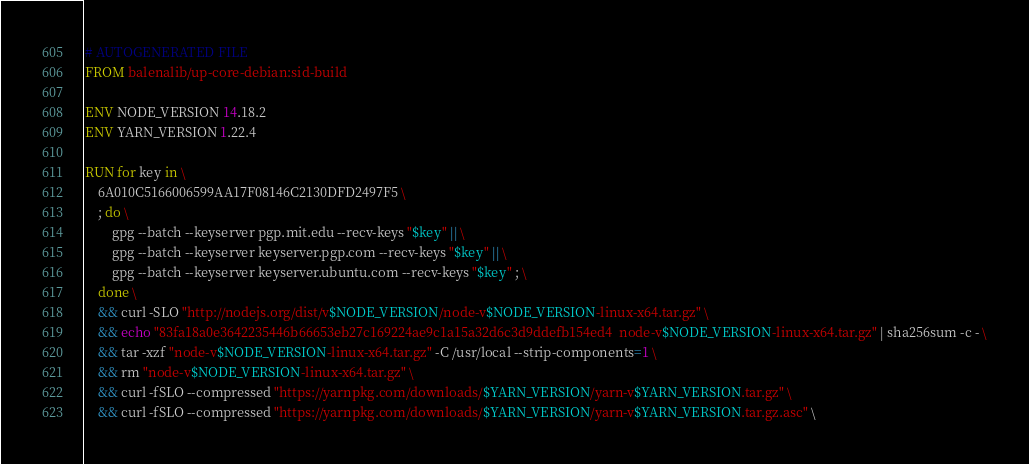<code> <loc_0><loc_0><loc_500><loc_500><_Dockerfile_># AUTOGENERATED FILE
FROM balenalib/up-core-debian:sid-build

ENV NODE_VERSION 14.18.2
ENV YARN_VERSION 1.22.4

RUN for key in \
	6A010C5166006599AA17F08146C2130DFD2497F5 \
	; do \
		gpg --batch --keyserver pgp.mit.edu --recv-keys "$key" || \
		gpg --batch --keyserver keyserver.pgp.com --recv-keys "$key" || \
		gpg --batch --keyserver keyserver.ubuntu.com --recv-keys "$key" ; \
	done \
	&& curl -SLO "http://nodejs.org/dist/v$NODE_VERSION/node-v$NODE_VERSION-linux-x64.tar.gz" \
	&& echo "83fa18a0e3642235446b66653eb27c169224ae9c1a15a32d6c3d9ddefb154ed4  node-v$NODE_VERSION-linux-x64.tar.gz" | sha256sum -c - \
	&& tar -xzf "node-v$NODE_VERSION-linux-x64.tar.gz" -C /usr/local --strip-components=1 \
	&& rm "node-v$NODE_VERSION-linux-x64.tar.gz" \
	&& curl -fSLO --compressed "https://yarnpkg.com/downloads/$YARN_VERSION/yarn-v$YARN_VERSION.tar.gz" \
	&& curl -fSLO --compressed "https://yarnpkg.com/downloads/$YARN_VERSION/yarn-v$YARN_VERSION.tar.gz.asc" \</code> 